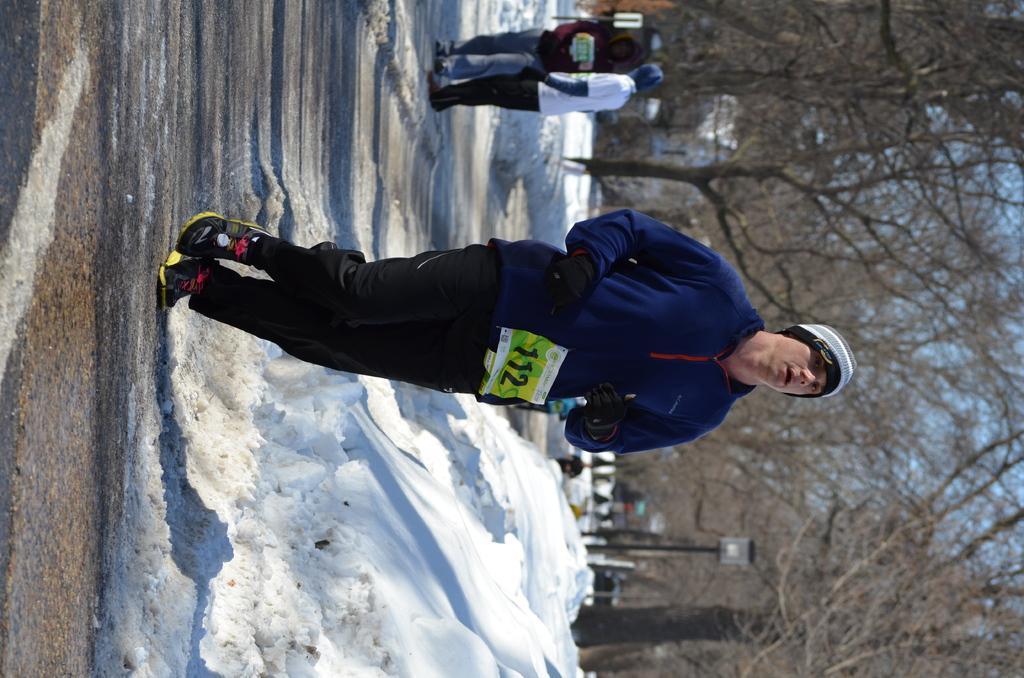How would you summarize this image in a sentence or two? In this image we can see a person wearing cap, gloves and chest number. On the ground there is snow. In the background there are few people. Also there are trees. 